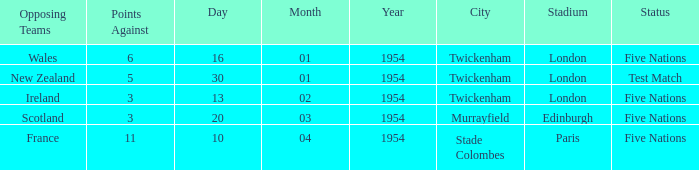What was the venue for the game played on 13/02/1954? Twickenham , London. 